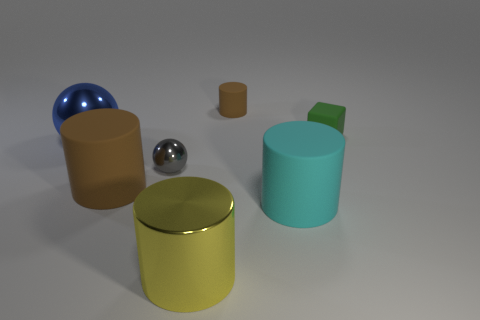There is a large rubber cylinder that is left of the large metal cylinder; what is its color?
Your answer should be very brief. Brown. Are there any other cylinders of the same color as the small matte cylinder?
Ensure brevity in your answer.  Yes. There is a shiny ball that is the same size as the yellow metal object; what is its color?
Your response must be concise. Blue. Is the blue object the same shape as the green thing?
Your response must be concise. No. What material is the tiny thing in front of the tiny green rubber object?
Provide a short and direct response. Metal. The rubber block is what color?
Keep it short and to the point. Green. There is a brown matte object that is behind the blue sphere; is its size the same as the gray metal sphere in front of the green matte object?
Provide a succinct answer. Yes. There is a matte object that is both behind the small shiny object and to the left of the tiny green rubber thing; what size is it?
Ensure brevity in your answer.  Small. There is a large metallic object that is the same shape as the small brown matte object; what color is it?
Provide a succinct answer. Yellow. Is the number of tiny gray spheres that are in front of the small green block greater than the number of large things left of the large brown matte cylinder?
Provide a short and direct response. No. 